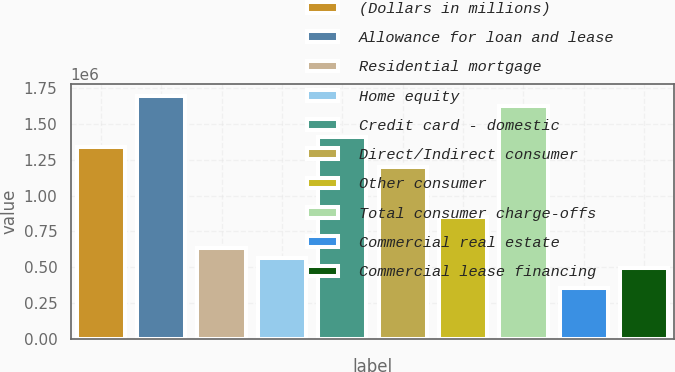Convert chart to OTSL. <chart><loc_0><loc_0><loc_500><loc_500><bar_chart><fcel>(Dollars in millions)<fcel>Allowance for loan and lease<fcel>Residential mortgage<fcel>Home equity<fcel>Credit card - domestic<fcel>Direct/Indirect consumer<fcel>Other consumer<fcel>Total consumer charge-offs<fcel>Commercial real estate<fcel>Commercial lease financing<nl><fcel>1.34233e+06<fcel>1.69558e+06<fcel>635841<fcel>565192<fcel>1.41298e+06<fcel>1.20103e+06<fcel>847788<fcel>1.62493e+06<fcel>353245<fcel>494543<nl></chart> 